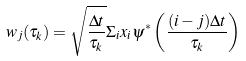Convert formula to latex. <formula><loc_0><loc_0><loc_500><loc_500>w _ { j } ( \tau _ { k } ) = \sqrt { \frac { \Delta t } { \tau _ { k } } } \Sigma _ { i } x _ { i } \psi ^ { * } \left ( \frac { ( i - j ) \Delta t } { \tau _ { k } } \right )</formula> 